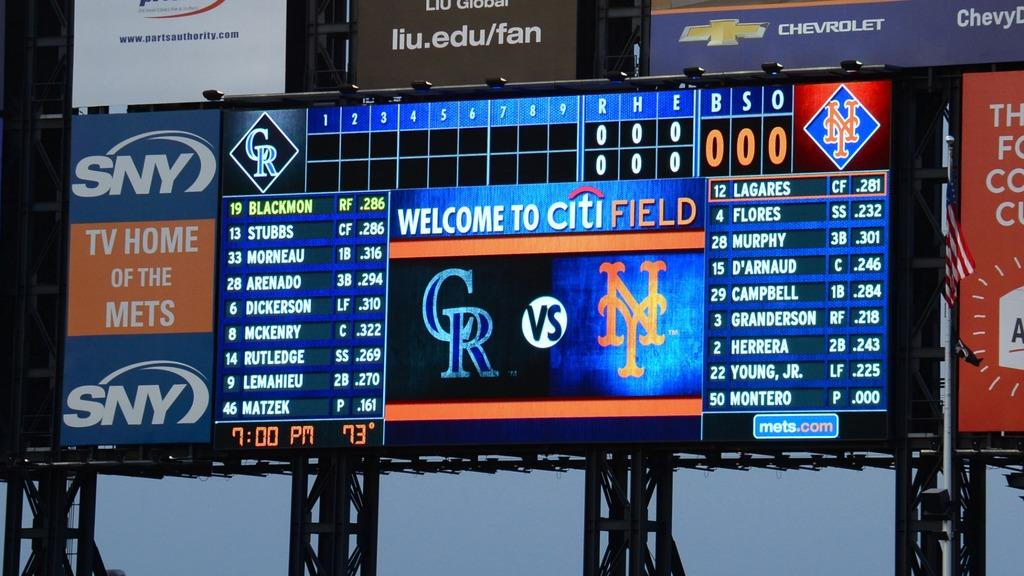What is located in the center of the image? There is a screen in the center of the image. What else can be seen in the center of the image besides the screen? There are posters in the center of the image. What is visible in the background of the image? There is a sky visible in the background of the image. How many police officers are visible in the image? There are no police officers present in the image. What type of vegetable can be seen growing in the center of the image? There is no vegetable present in the image. How many sheep are visible in the image? There are no sheep present in the image. 